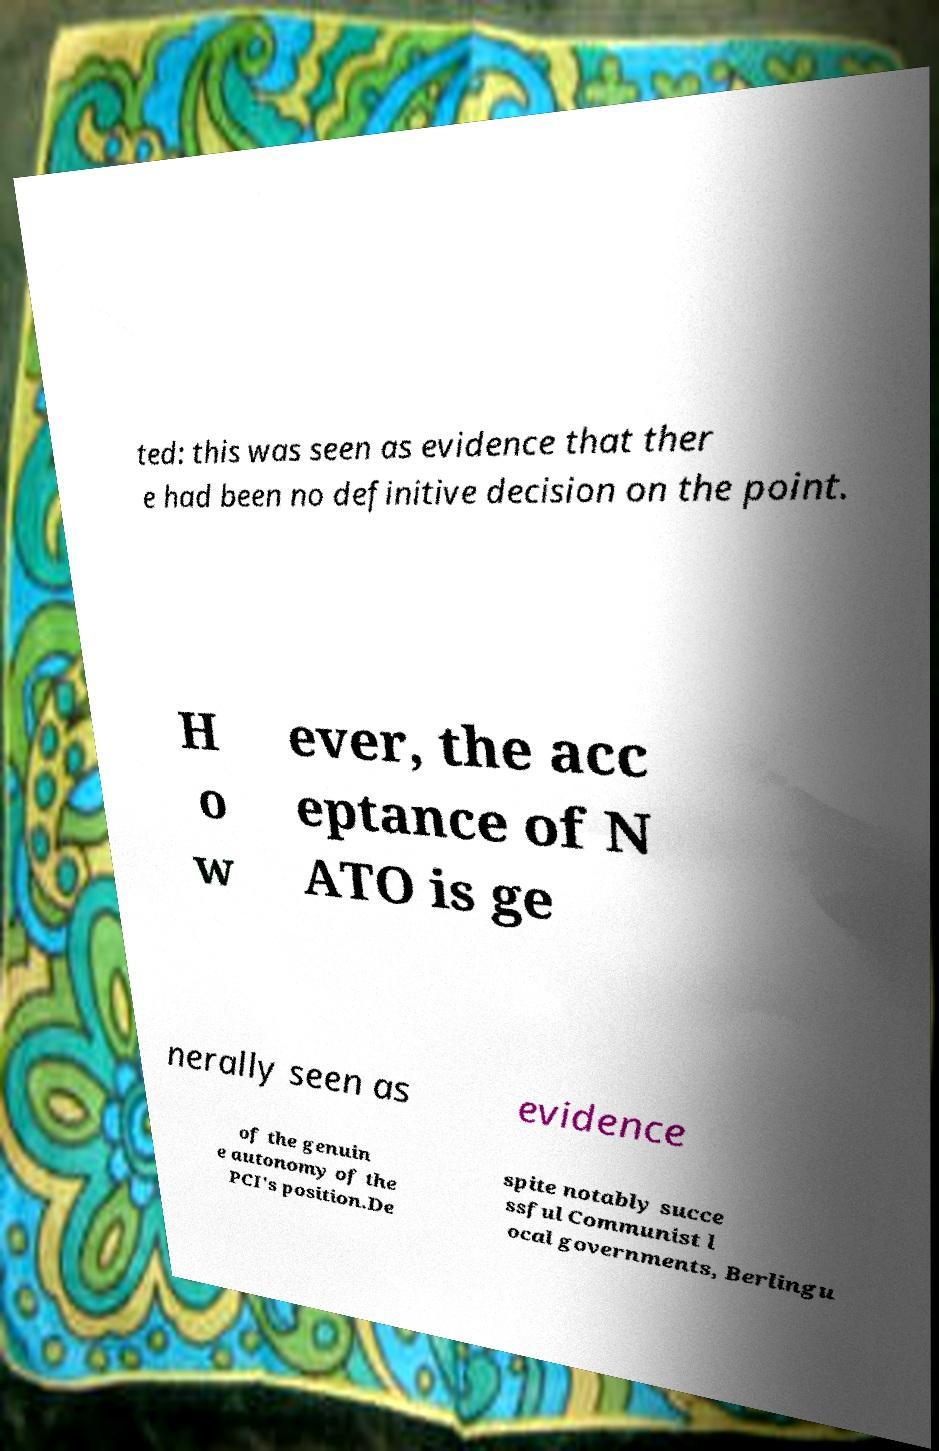Could you assist in decoding the text presented in this image and type it out clearly? ted: this was seen as evidence that ther e had been no definitive decision on the point. H o w ever, the acc eptance of N ATO is ge nerally seen as evidence of the genuin e autonomy of the PCI's position.De spite notably succe ssful Communist l ocal governments, Berlingu 